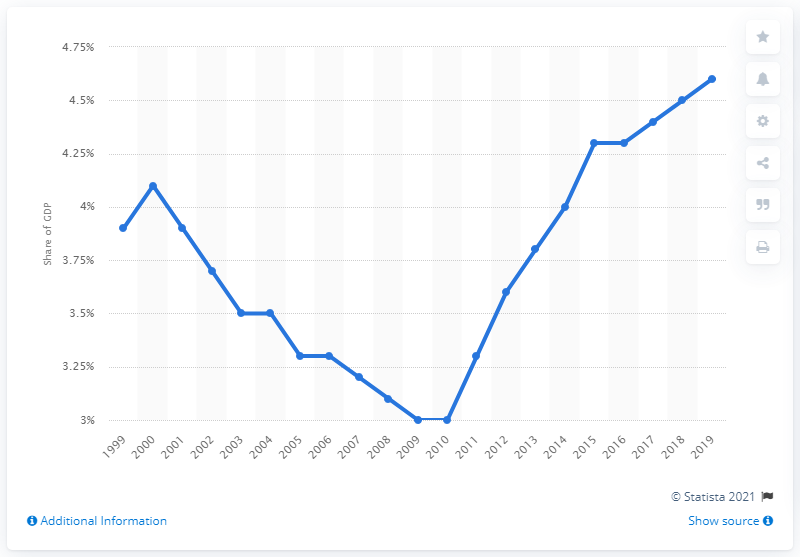Draw attention to some important aspects in this diagram. In the year 2010, leisure tourism spending in Italy experienced a significant increase. In 2019, Italy spent 4.6 billion USD on leisure tourism. 